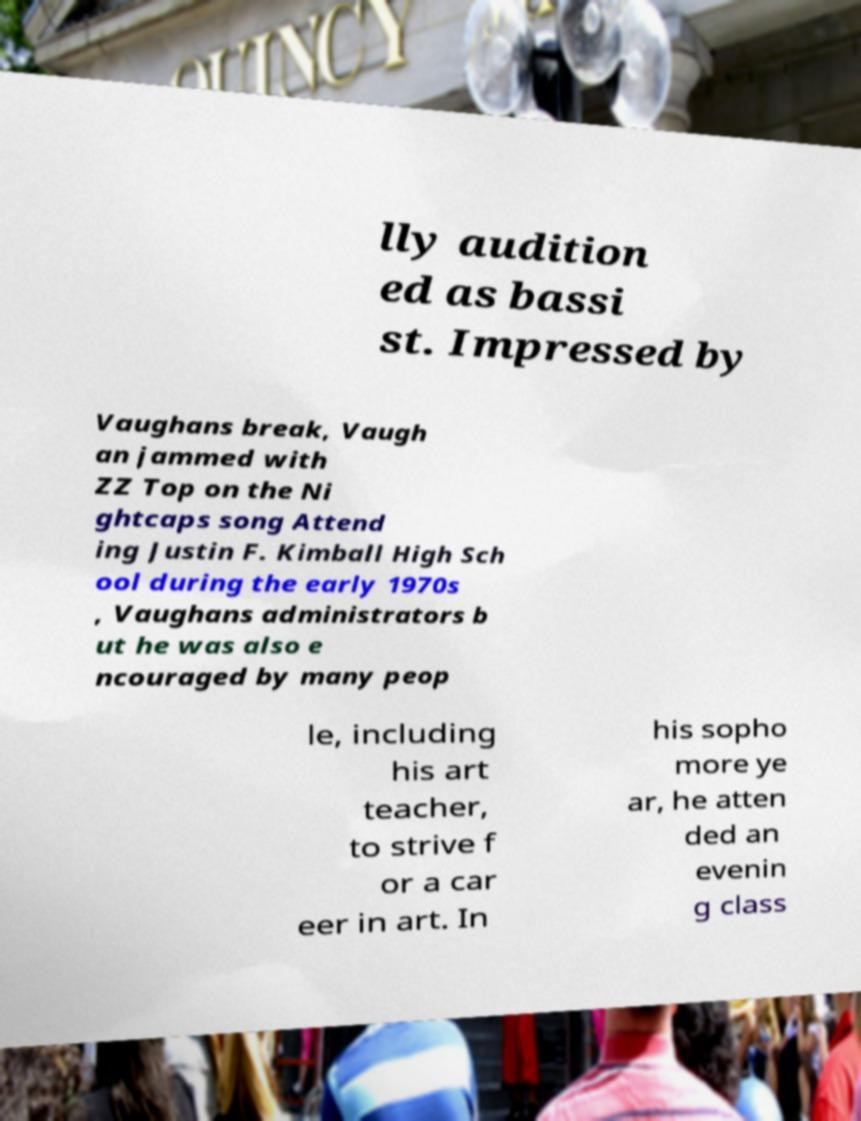For documentation purposes, I need the text within this image transcribed. Could you provide that? lly audition ed as bassi st. Impressed by Vaughans break, Vaugh an jammed with ZZ Top on the Ni ghtcaps song Attend ing Justin F. Kimball High Sch ool during the early 1970s , Vaughans administrators b ut he was also e ncouraged by many peop le, including his art teacher, to strive f or a car eer in art. In his sopho more ye ar, he atten ded an evenin g class 